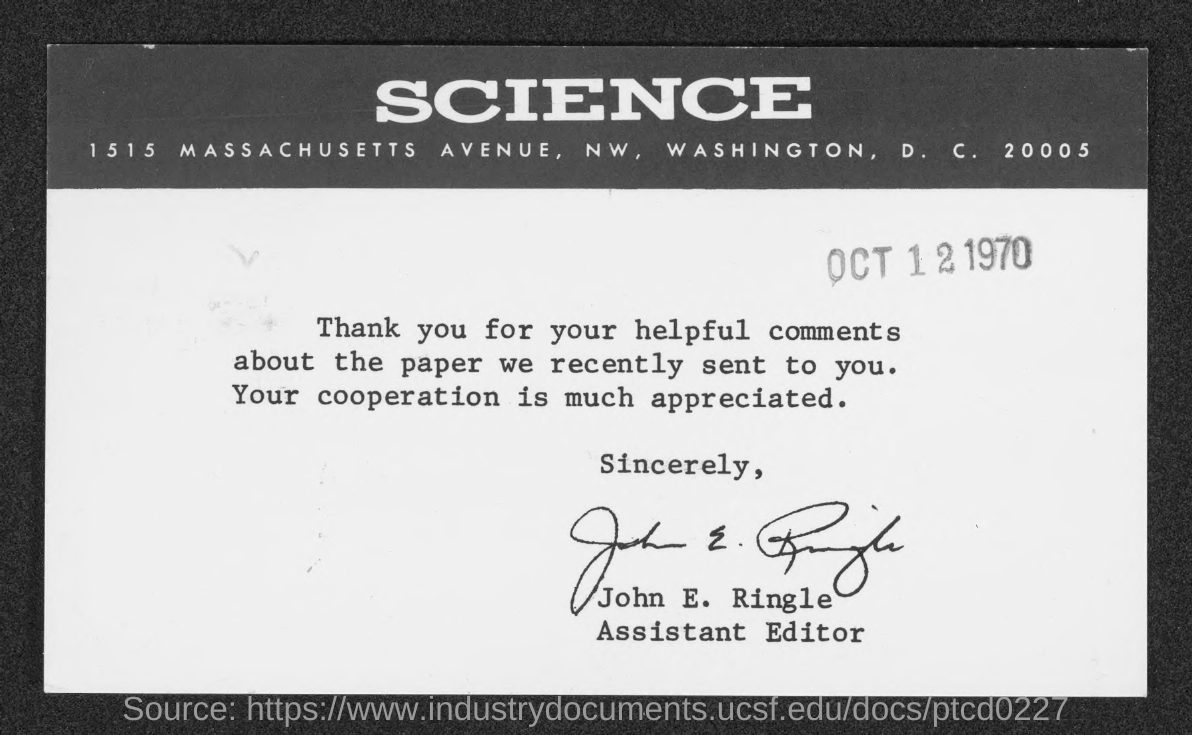When is the Memorandum dated on ?
Your answer should be compact. OCT 12 1970. Who is Assistant Editor ?
Your answer should be very brief. John E. Ringle. 